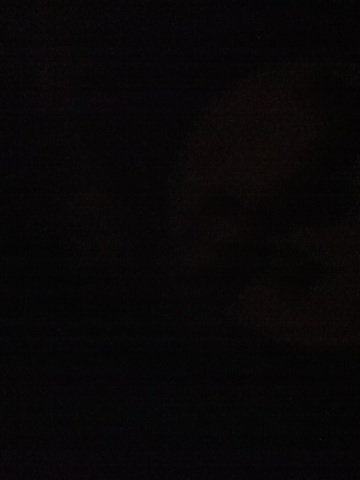Can you identify any visible features in this image? The image appears extremely dark, making it difficult to identify any specific features clearly. Could you describe or adjust the brightness? 